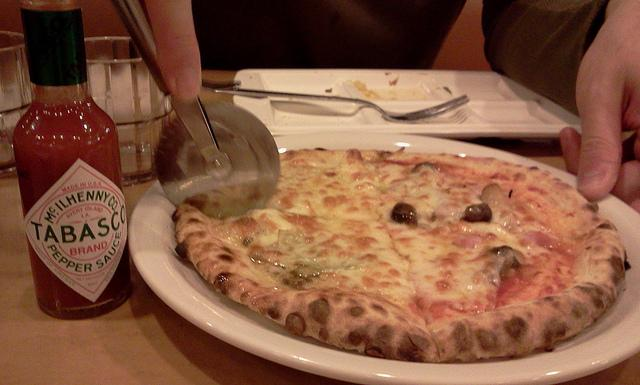The popular American brand of hot sauce is made up of what?

Choices:
A) chilly
B) tabasco peppers
C) peppercorn
D) capsicum tabasco peppers 